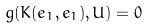<formula> <loc_0><loc_0><loc_500><loc_500>g ( K ( e _ { 1 } , e _ { 1 } ) , U ) = 0</formula> 